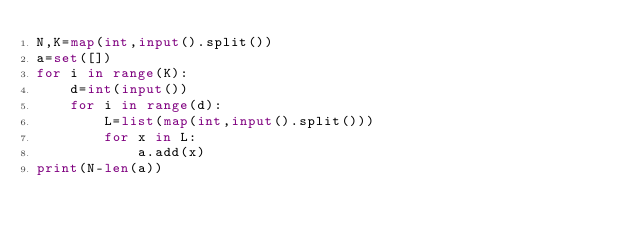Convert code to text. <code><loc_0><loc_0><loc_500><loc_500><_Python_>N,K=map(int,input().split())
a=set([])
for i in range(K):
    d=int(input())
    for i in range(d):
        L=list(map(int,input().split()))
        for x in L:
            a.add(x)
print(N-len(a))</code> 